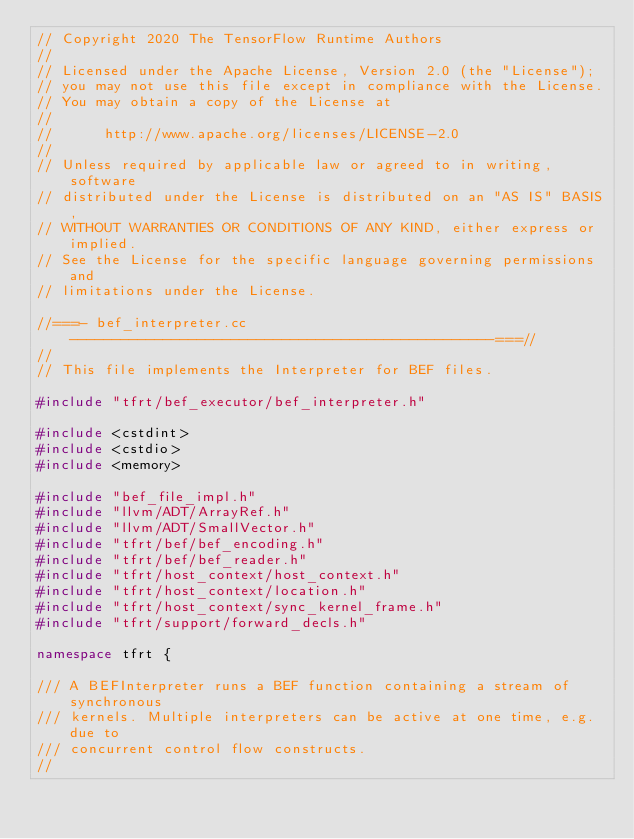<code> <loc_0><loc_0><loc_500><loc_500><_C++_>// Copyright 2020 The TensorFlow Runtime Authors
//
// Licensed under the Apache License, Version 2.0 (the "License");
// you may not use this file except in compliance with the License.
// You may obtain a copy of the License at
//
//      http://www.apache.org/licenses/LICENSE-2.0
//
// Unless required by applicable law or agreed to in writing, software
// distributed under the License is distributed on an "AS IS" BASIS,
// WITHOUT WARRANTIES OR CONDITIONS OF ANY KIND, either express or implied.
// See the License for the specific language governing permissions and
// limitations under the License.

//===- bef_interpreter.cc--------------------------------------------------===//
//
// This file implements the Interpreter for BEF files.

#include "tfrt/bef_executor/bef_interpreter.h"

#include <cstdint>
#include <cstdio>
#include <memory>

#include "bef_file_impl.h"
#include "llvm/ADT/ArrayRef.h"
#include "llvm/ADT/SmallVector.h"
#include "tfrt/bef/bef_encoding.h"
#include "tfrt/bef/bef_reader.h"
#include "tfrt/host_context/host_context.h"
#include "tfrt/host_context/location.h"
#include "tfrt/host_context/sync_kernel_frame.h"
#include "tfrt/support/forward_decls.h"

namespace tfrt {

/// A BEFInterpreter runs a BEF function containing a stream of synchronous
/// kernels. Multiple interpreters can be active at one time, e.g. due to
/// concurrent control flow constructs.
//</code> 